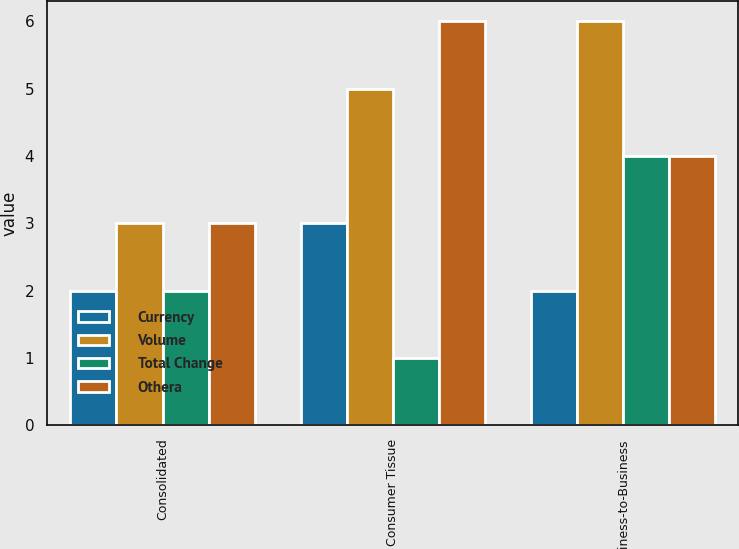Convert chart. <chart><loc_0><loc_0><loc_500><loc_500><stacked_bar_chart><ecel><fcel>Consolidated<fcel>Consumer Tissue<fcel>Business-to-Business<nl><fcel>Currency<fcel>2<fcel>3<fcel>2<nl><fcel>Volume<fcel>3<fcel>5<fcel>6<nl><fcel>Total Change<fcel>2<fcel>1<fcel>4<nl><fcel>Othera<fcel>3<fcel>6<fcel>4<nl></chart> 